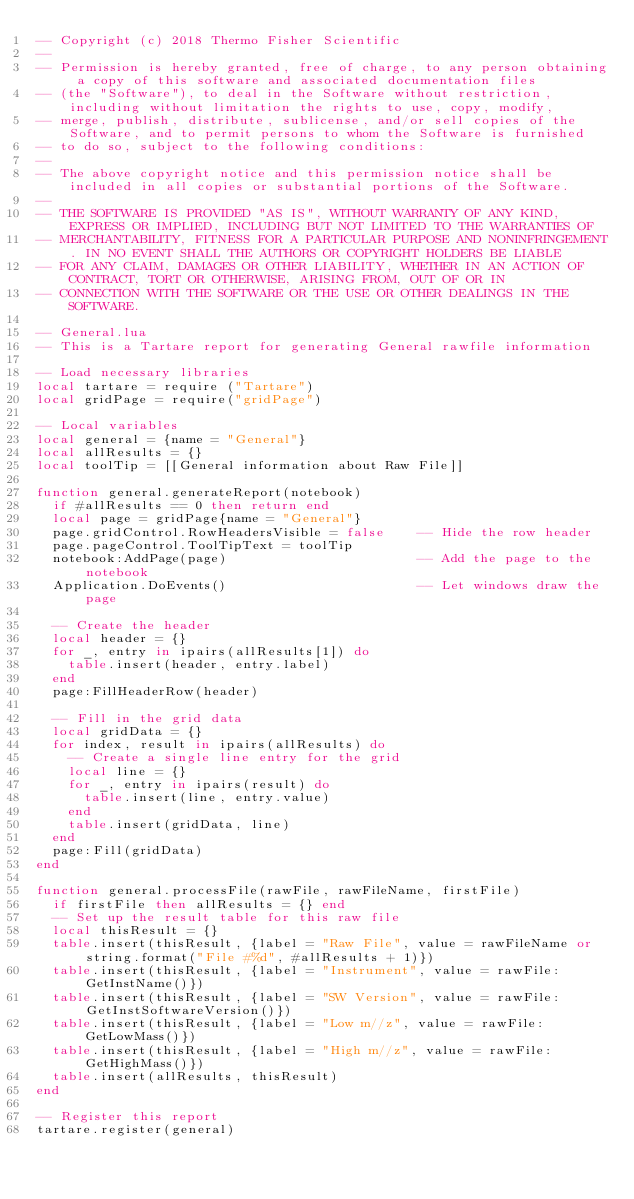Convert code to text. <code><loc_0><loc_0><loc_500><loc_500><_Lua_>-- Copyright (c) 2018 Thermo Fisher Scientific
--
-- Permission is hereby granted, free of charge, to any person obtaining a copy of this software and associated documentation files
-- (the "Software"), to deal in the Software without restriction, including without limitation the rights to use, copy, modify,
-- merge, publish, distribute, sublicense, and/or sell copies of the Software, and to permit persons to whom the Software is furnished
-- to do so, subject to the following conditions:
--
-- The above copyright notice and this permission notice shall be included in all copies or substantial portions of the Software.
--
-- THE SOFTWARE IS PROVIDED "AS IS", WITHOUT WARRANTY OF ANY KIND, EXPRESS OR IMPLIED, INCLUDING BUT NOT LIMITED TO THE WARRANTIES OF
-- MERCHANTABILITY, FITNESS FOR A PARTICULAR PURPOSE AND NONINFRINGEMENT. IN NO EVENT SHALL THE AUTHORS OR COPYRIGHT HOLDERS BE LIABLE
-- FOR ANY CLAIM, DAMAGES OR OTHER LIABILITY, WHETHER IN AN ACTION OF CONTRACT, TORT OR OTHERWISE, ARISING FROM, OUT OF OR IN
-- CONNECTION WITH THE SOFTWARE OR THE USE OR OTHER DEALINGS IN THE SOFTWARE.

-- General.lua
-- This is a Tartare report for generating General rawfile information

-- Load necessary libraries
local tartare = require ("Tartare")
local gridPage = require("gridPage")

-- Local variables
local general = {name = "General"}
local allResults = {}
local toolTip = [[General information about Raw File]]

function general.generateReport(notebook)
  if #allResults == 0 then return end
  local page = gridPage{name = "General"}
  page.gridControl.RowHeadersVisible = false    -- Hide the row header
  page.pageControl.ToolTipText = toolTip
  notebook:AddPage(page)                        -- Add the page to the notebook
  Application.DoEvents()                        -- Let windows draw the page
  
  -- Create the header
  local header = {}
  for _, entry in ipairs(allResults[1]) do
    table.insert(header, entry.label)
  end
  page:FillHeaderRow(header)

  -- Fill in the grid data
  local gridData = {}
  for index, result in ipairs(allResults) do
    -- Create a single line entry for the grid
    local line = {}
    for _, entry in ipairs(result) do
      table.insert(line, entry.value)
    end
    table.insert(gridData, line)
  end
  page:Fill(gridData)
end

function general.processFile(rawFile, rawFileName, firstFile)
  if firstFile then allResults = {} end
  -- Set up the result table for this raw file
  local thisResult = {}
  table.insert(thisResult, {label = "Raw File", value = rawFileName or string.format("File #%d", #allResults + 1)})
  table.insert(thisResult, {label = "Instrument", value = rawFile:GetInstName()})
  table.insert(thisResult, {label = "SW Version", value = rawFile:GetInstSoftwareVersion()})
  table.insert(thisResult, {label = "Low m//z", value = rawFile:GetLowMass()})
  table.insert(thisResult, {label = "High m//z", value = rawFile:GetHighMass()})
  table.insert(allResults, thisResult)
end

-- Register this report
tartare.register(general)
</code> 